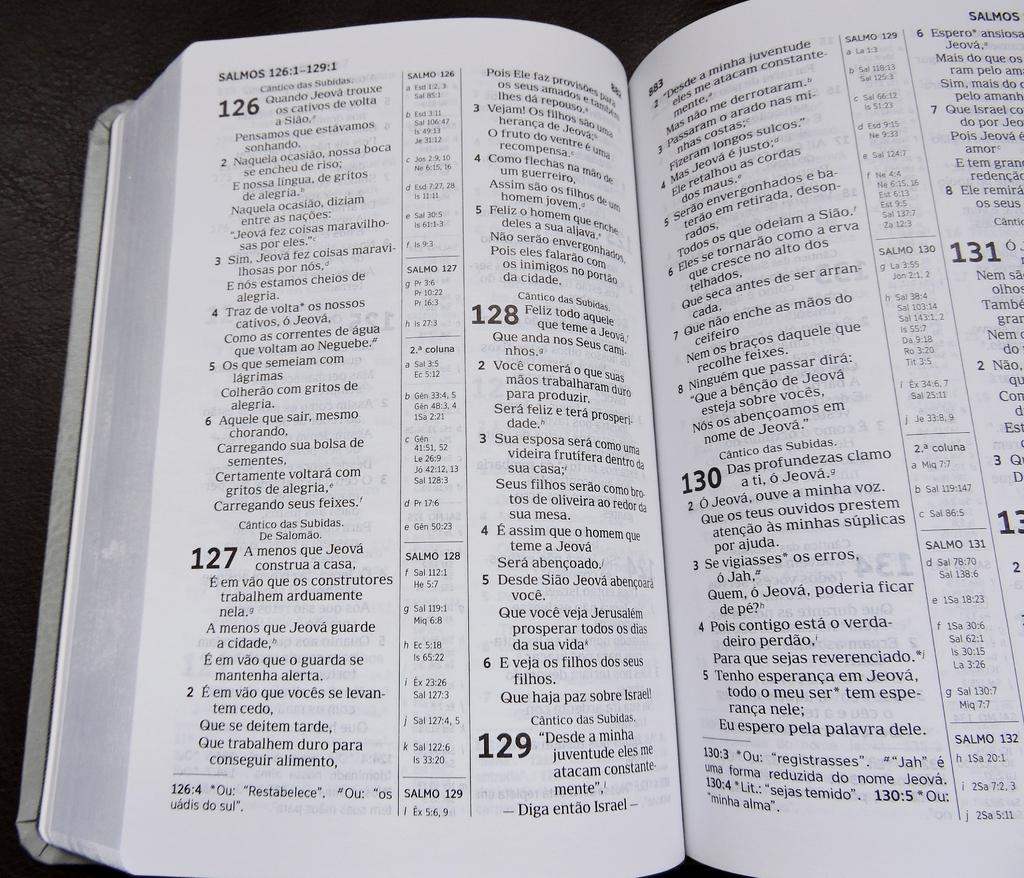Provide a one-sentence caption for the provided image. A book of Psalms shows number 126 through number 131. 